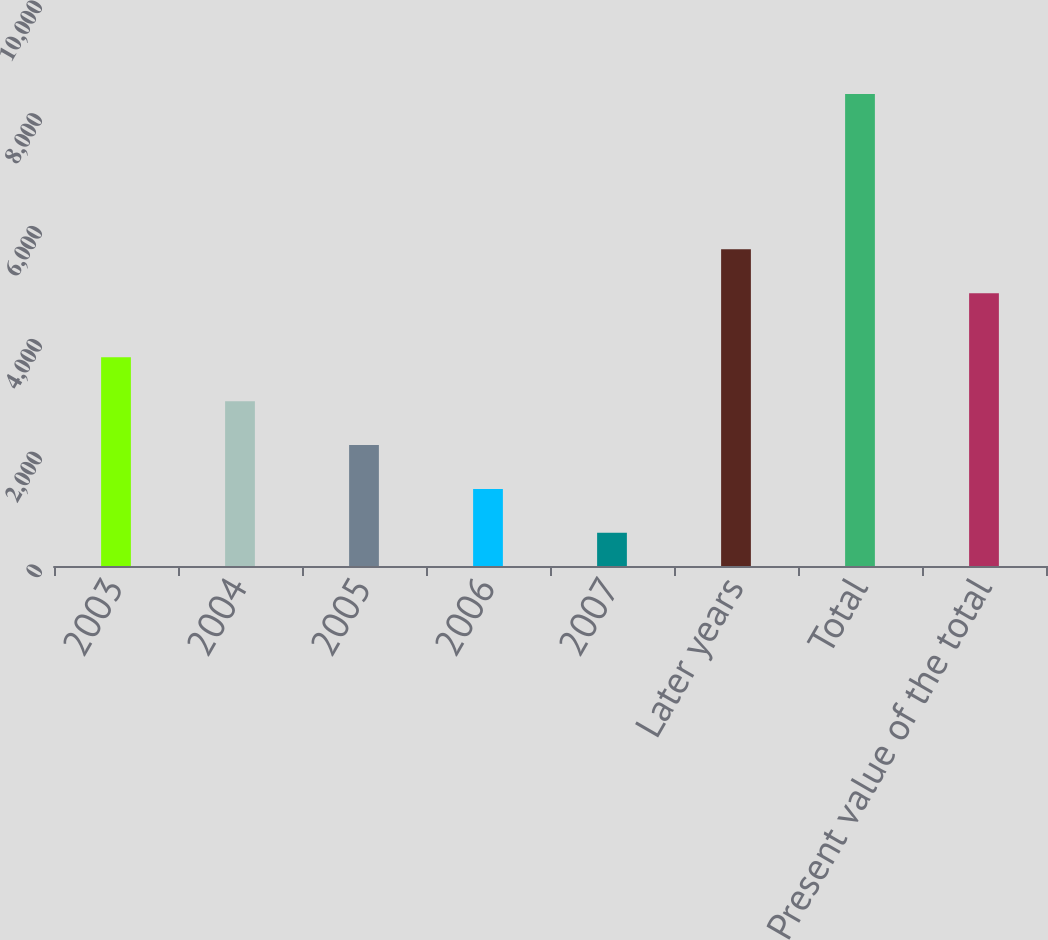Convert chart. <chart><loc_0><loc_0><loc_500><loc_500><bar_chart><fcel>2003<fcel>2004<fcel>2005<fcel>2006<fcel>2007<fcel>Later years<fcel>Total<fcel>Present value of the total<nl><fcel>3701<fcel>2923<fcel>2145<fcel>1367<fcel>589<fcel>5614<fcel>8369<fcel>4836<nl></chart> 